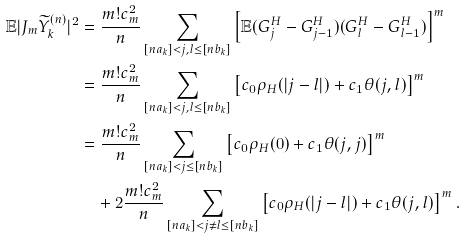<formula> <loc_0><loc_0><loc_500><loc_500>\mathbb { E } | J _ { m } \widetilde { Y } _ { k } ^ { ( n ) } | ^ { 2 } & = \frac { m ! c _ { m } ^ { 2 } } { n } \sum _ { [ n a _ { k } ] < j , l \leq [ n b _ { k } ] } \left [ \mathbb { E } ( G ^ { H } _ { j } - G ^ { H } _ { j - 1 } ) ( G ^ { H } _ { l } - G ^ { H } _ { l - 1 } ) \right ] ^ { m } \\ & = \frac { m ! c _ { m } ^ { 2 } } { n } \sum _ { [ n a _ { k } ] < j , l \leq [ n b _ { k } ] } \left [ c _ { 0 } \rho _ { H } ( | j - l | ) + c _ { 1 } \theta ( j , l ) \right ] ^ { m } \\ & = \frac { m ! c _ { m } ^ { 2 } } { n } \sum _ { [ n a _ { k } ] < j \leq [ n b _ { k } ] } \left [ c _ { 0 } \rho _ { H } ( 0 ) + c _ { 1 } \theta ( j , j ) \right ] ^ { m } \\ & \quad + 2 \frac { m ! c _ { m } ^ { 2 } } { n } \sum _ { [ n a _ { k } ] < j \neq l \leq [ n b _ { k } ] } \left [ c _ { 0 } \rho _ { H } ( | j - l | ) + c _ { 1 } \theta ( j , l ) \right ] ^ { m } .</formula> 